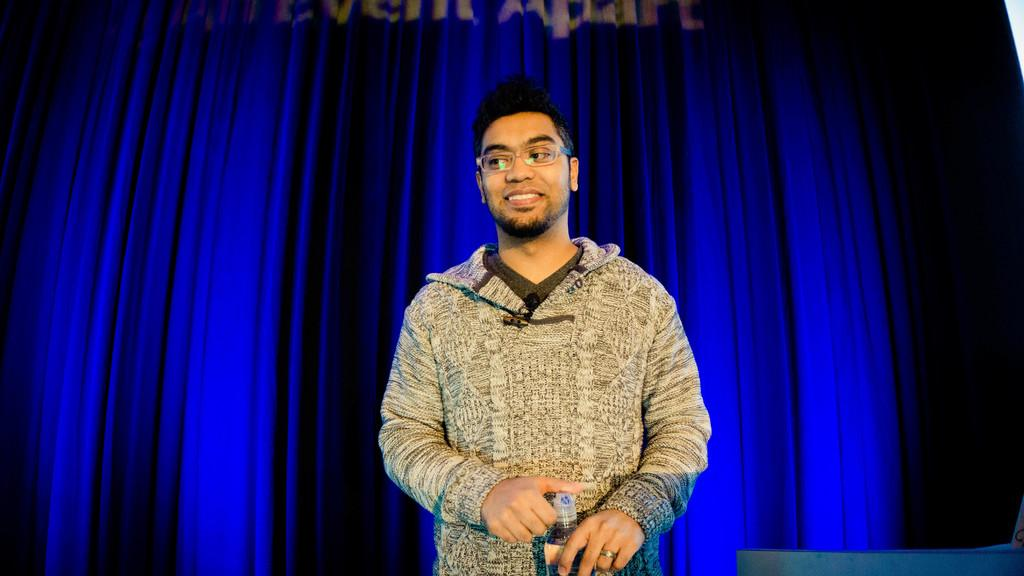Who or what is the main subject in the image? There is a person in the center of the image. What is the person holding in his hand? The person is holding a bottle in his hand. Can you describe the background of the image? There is a blue color curtain in the background of the image. How many turkeys can be seen flying in the sky in the image? There are no turkeys or sky visible in the image; it only features a person holding a bottle and a blue curtain in the background. 